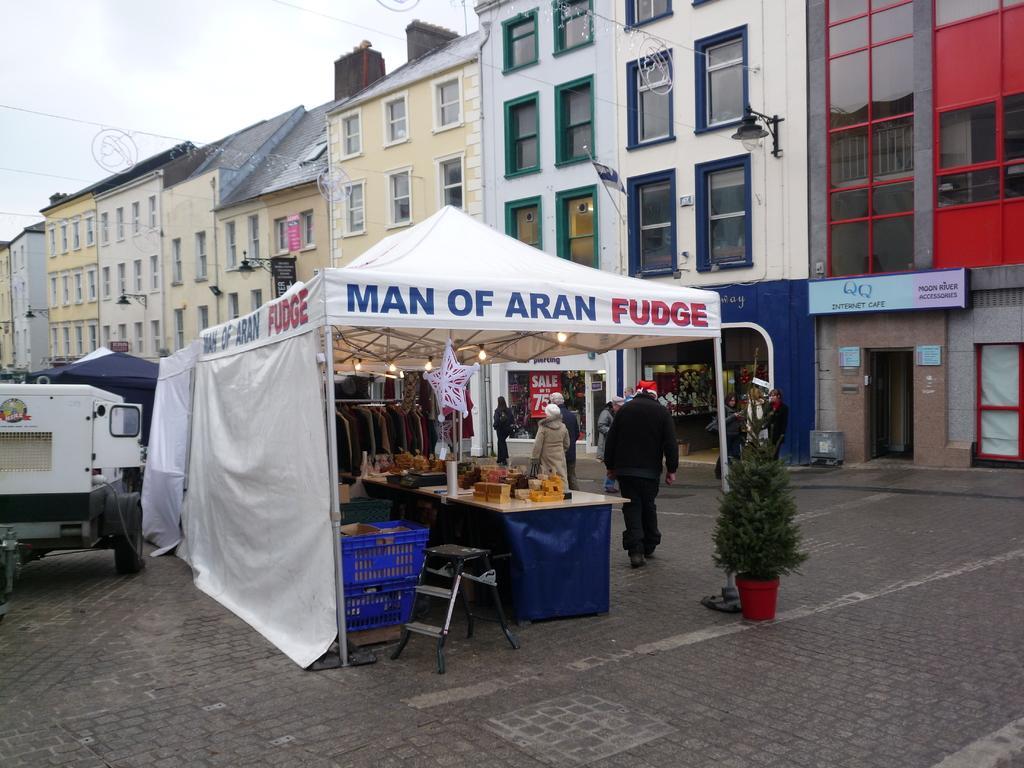Could you give a brief overview of what you see in this image? In this picture we can see some persons are standing on the road. This is plant and there is a stall. Here we can see a table and this is chair. On the background we can see some buildings. And there is a vehicle. And this is sky. 